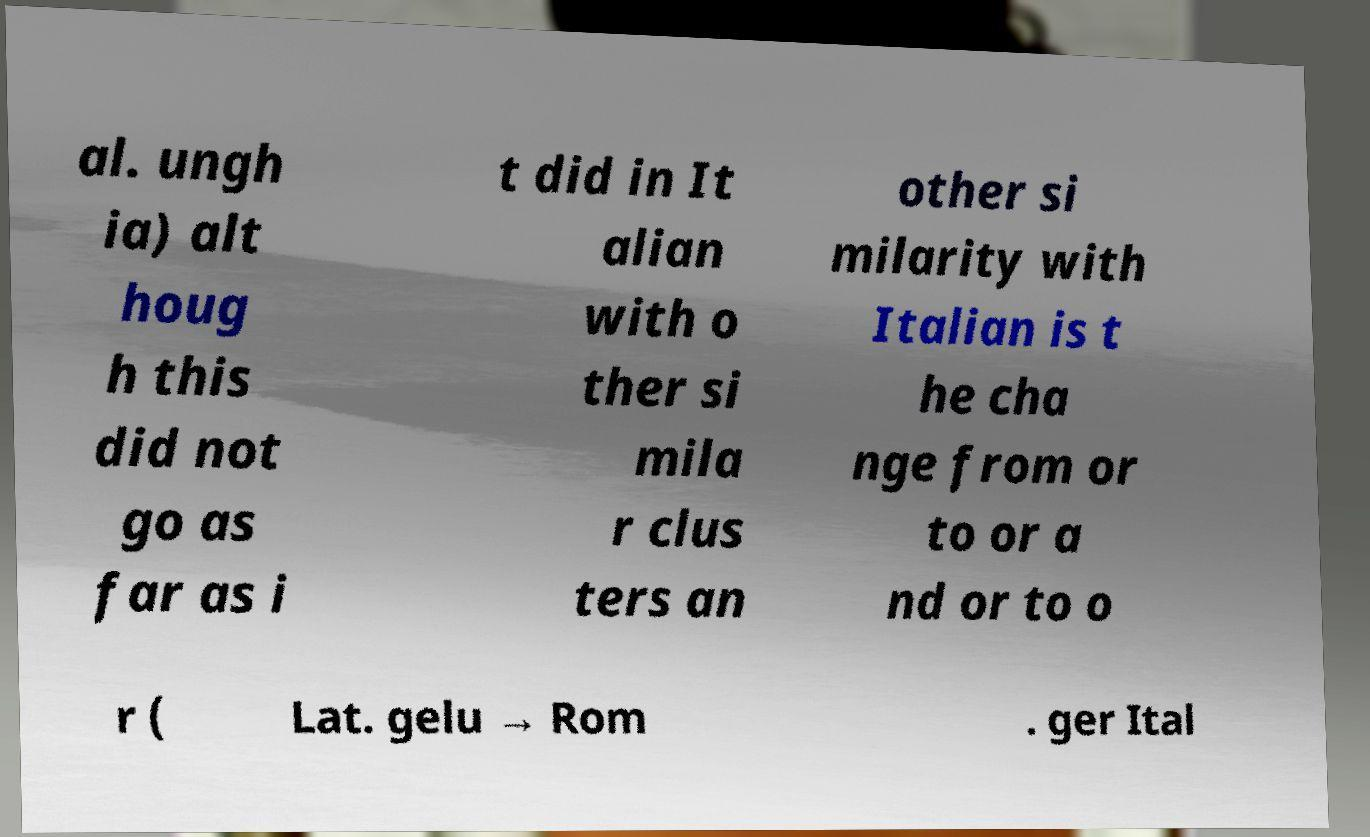What messages or text are displayed in this image? I need them in a readable, typed format. al. ungh ia) alt houg h this did not go as far as i t did in It alian with o ther si mila r clus ters an other si milarity with Italian is t he cha nge from or to or a nd or to o r ( Lat. gelu → Rom . ger Ital 